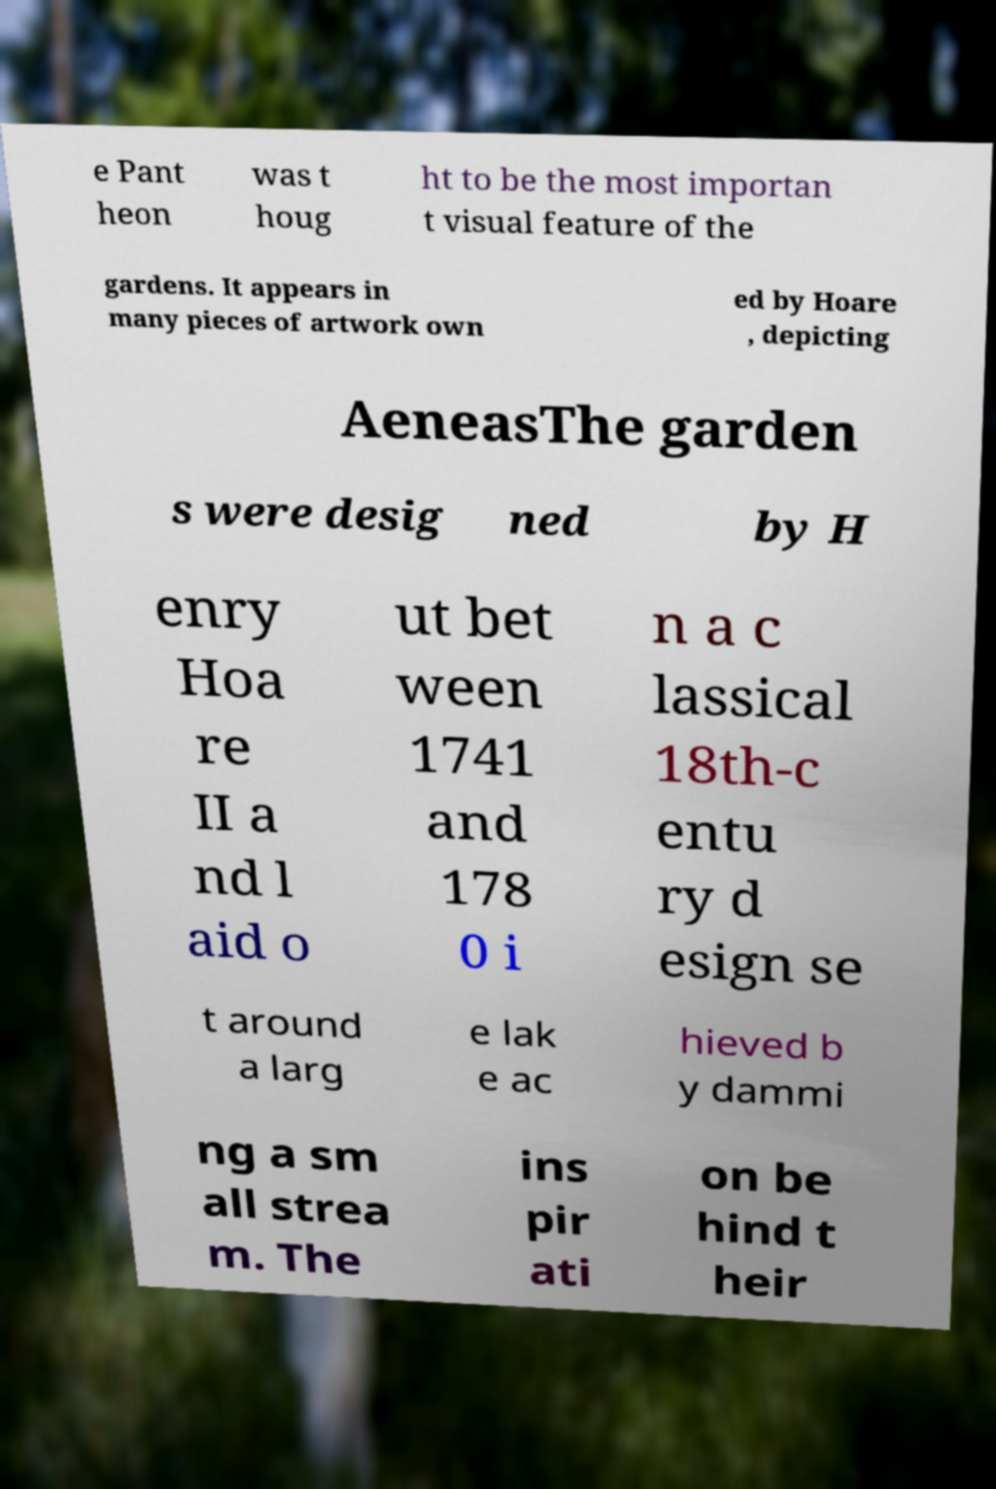Please read and relay the text visible in this image. What does it say? e Pant heon was t houg ht to be the most importan t visual feature of the gardens. It appears in many pieces of artwork own ed by Hoare , depicting AeneasThe garden s were desig ned by H enry Hoa re II a nd l aid o ut bet ween 1741 and 178 0 i n a c lassical 18th-c entu ry d esign se t around a larg e lak e ac hieved b y dammi ng a sm all strea m. The ins pir ati on be hind t heir 